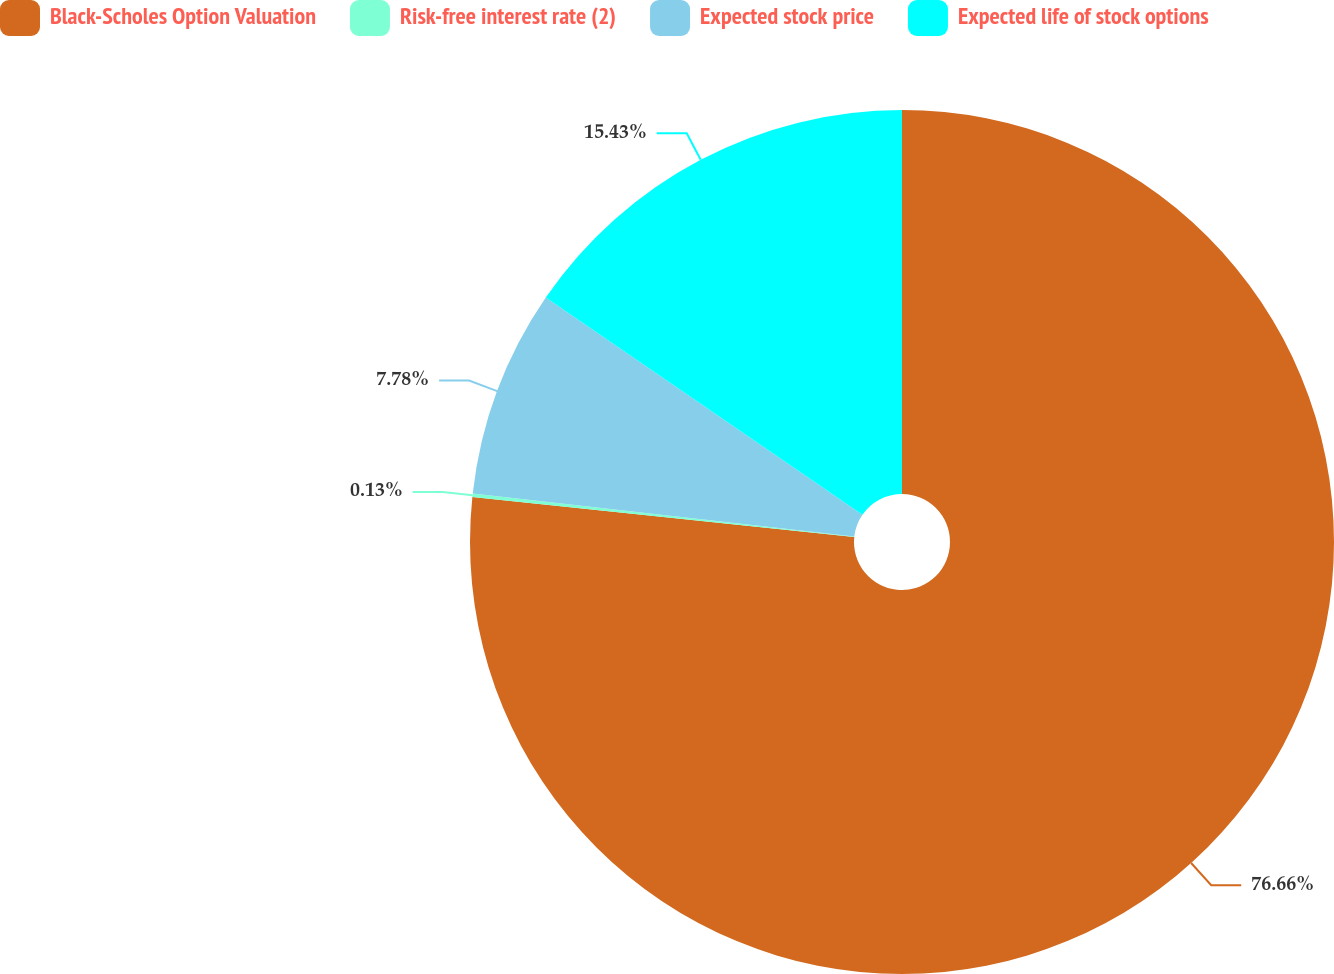<chart> <loc_0><loc_0><loc_500><loc_500><pie_chart><fcel>Black-Scholes Option Valuation<fcel>Risk-free interest rate (2)<fcel>Expected stock price<fcel>Expected life of stock options<nl><fcel>76.66%<fcel>0.13%<fcel>7.78%<fcel>15.43%<nl></chart> 